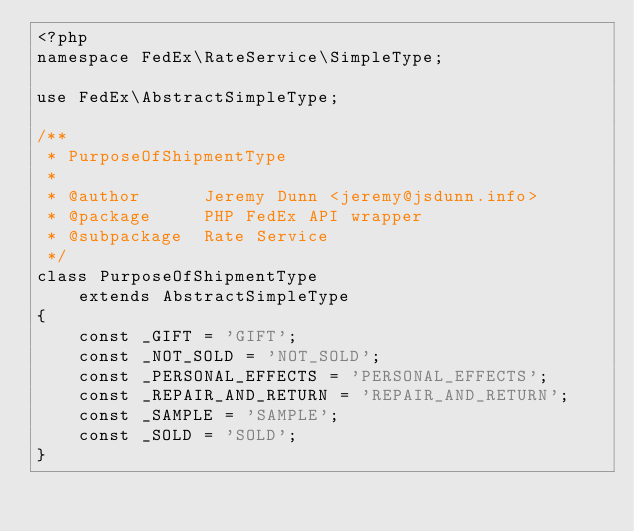<code> <loc_0><loc_0><loc_500><loc_500><_PHP_><?php
namespace FedEx\RateService\SimpleType;

use FedEx\AbstractSimpleType;

/**
 * PurposeOfShipmentType
 *
 * @author      Jeremy Dunn <jeremy@jsdunn.info>
 * @package     PHP FedEx API wrapper
 * @subpackage  Rate Service
 */
class PurposeOfShipmentType
    extends AbstractSimpleType
{
    const _GIFT = 'GIFT';
    const _NOT_SOLD = 'NOT_SOLD';
    const _PERSONAL_EFFECTS = 'PERSONAL_EFFECTS';
    const _REPAIR_AND_RETURN = 'REPAIR_AND_RETURN';
    const _SAMPLE = 'SAMPLE';
    const _SOLD = 'SOLD';
}</code> 